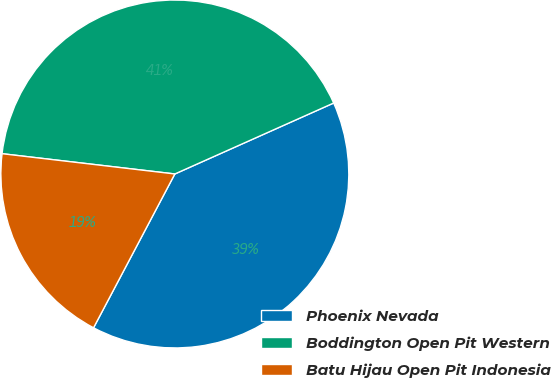Convert chart to OTSL. <chart><loc_0><loc_0><loc_500><loc_500><pie_chart><fcel>Phoenix Nevada<fcel>Boddington Open Pit Western<fcel>Batu Hijau Open Pit Indonesia<nl><fcel>39.42%<fcel>41.45%<fcel>19.12%<nl></chart> 